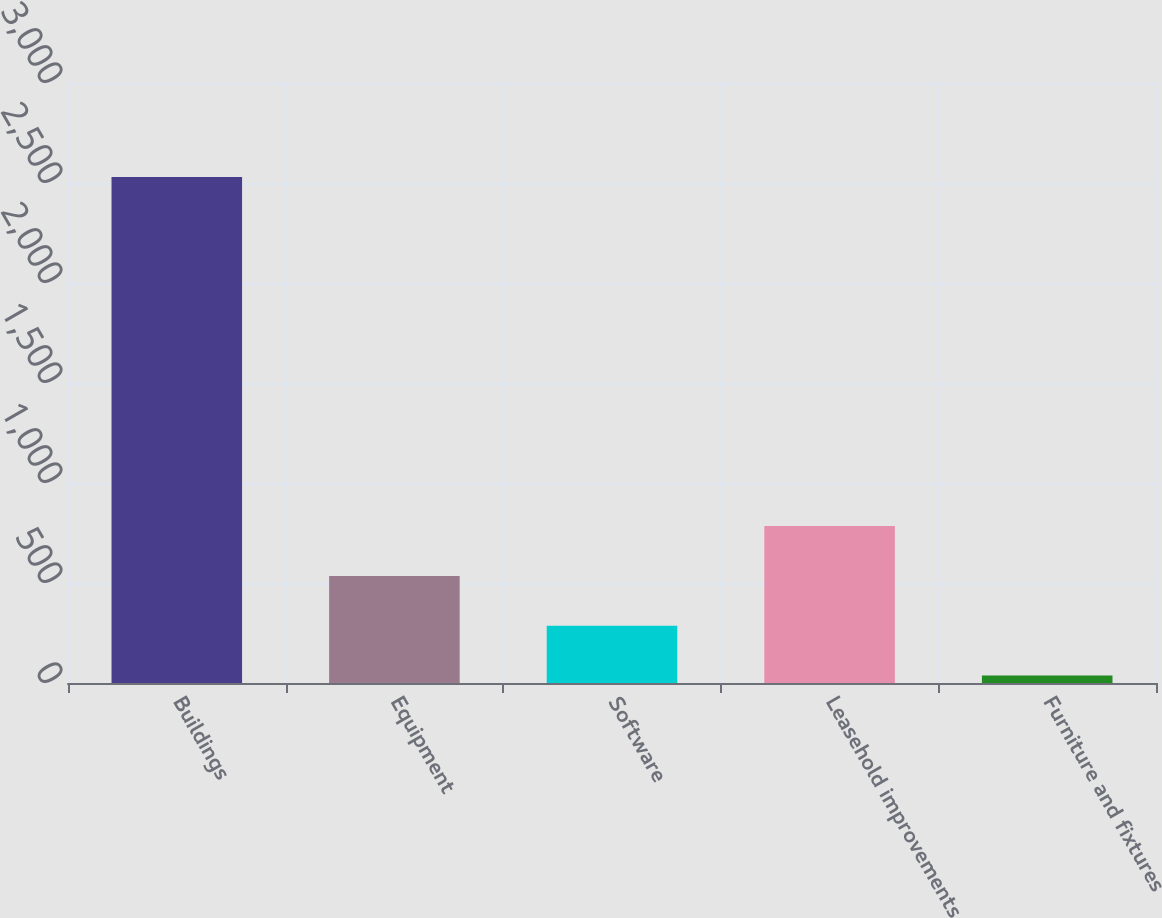Convert chart to OTSL. <chart><loc_0><loc_0><loc_500><loc_500><bar_chart><fcel>Buildings<fcel>Equipment<fcel>Software<fcel>Leasehold improvements<fcel>Furniture and fixtures<nl><fcel>2530<fcel>535.6<fcel>286.3<fcel>784.9<fcel>37<nl></chart> 